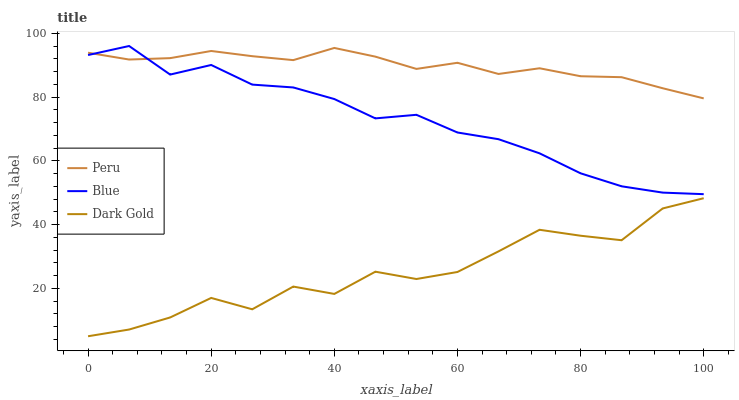Does Peru have the minimum area under the curve?
Answer yes or no. No. Does Dark Gold have the maximum area under the curve?
Answer yes or no. No. Is Dark Gold the smoothest?
Answer yes or no. No. Is Peru the roughest?
Answer yes or no. No. Does Peru have the lowest value?
Answer yes or no. No. Does Peru have the highest value?
Answer yes or no. No. Is Dark Gold less than Peru?
Answer yes or no. Yes. Is Peru greater than Dark Gold?
Answer yes or no. Yes. Does Dark Gold intersect Peru?
Answer yes or no. No. 